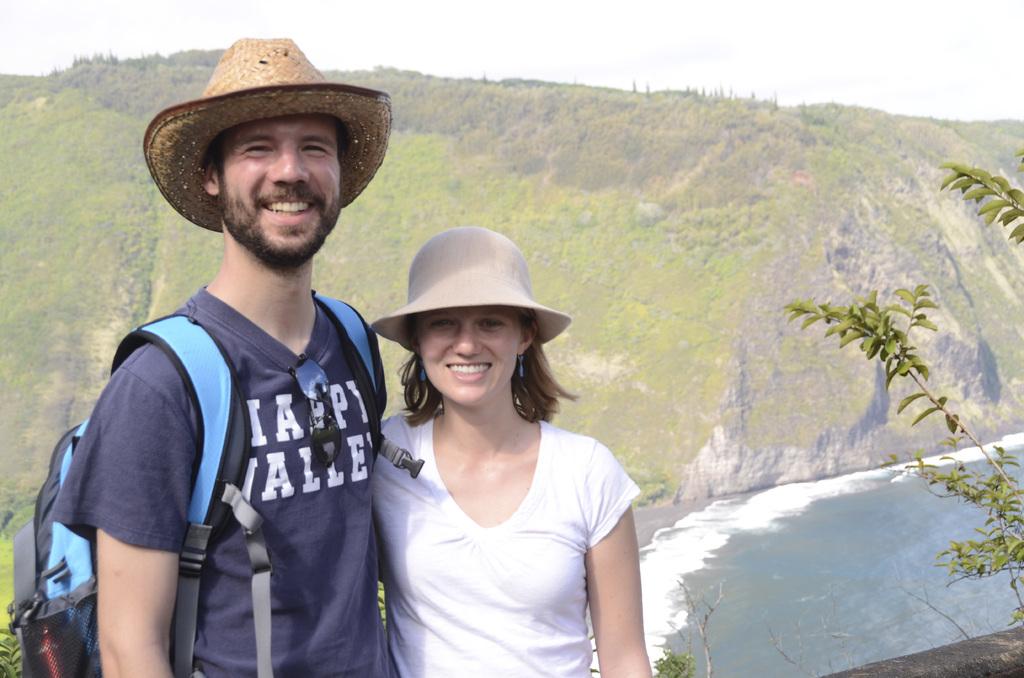What does it say on his t-shirt?
Provide a short and direct response. Happy valley. 